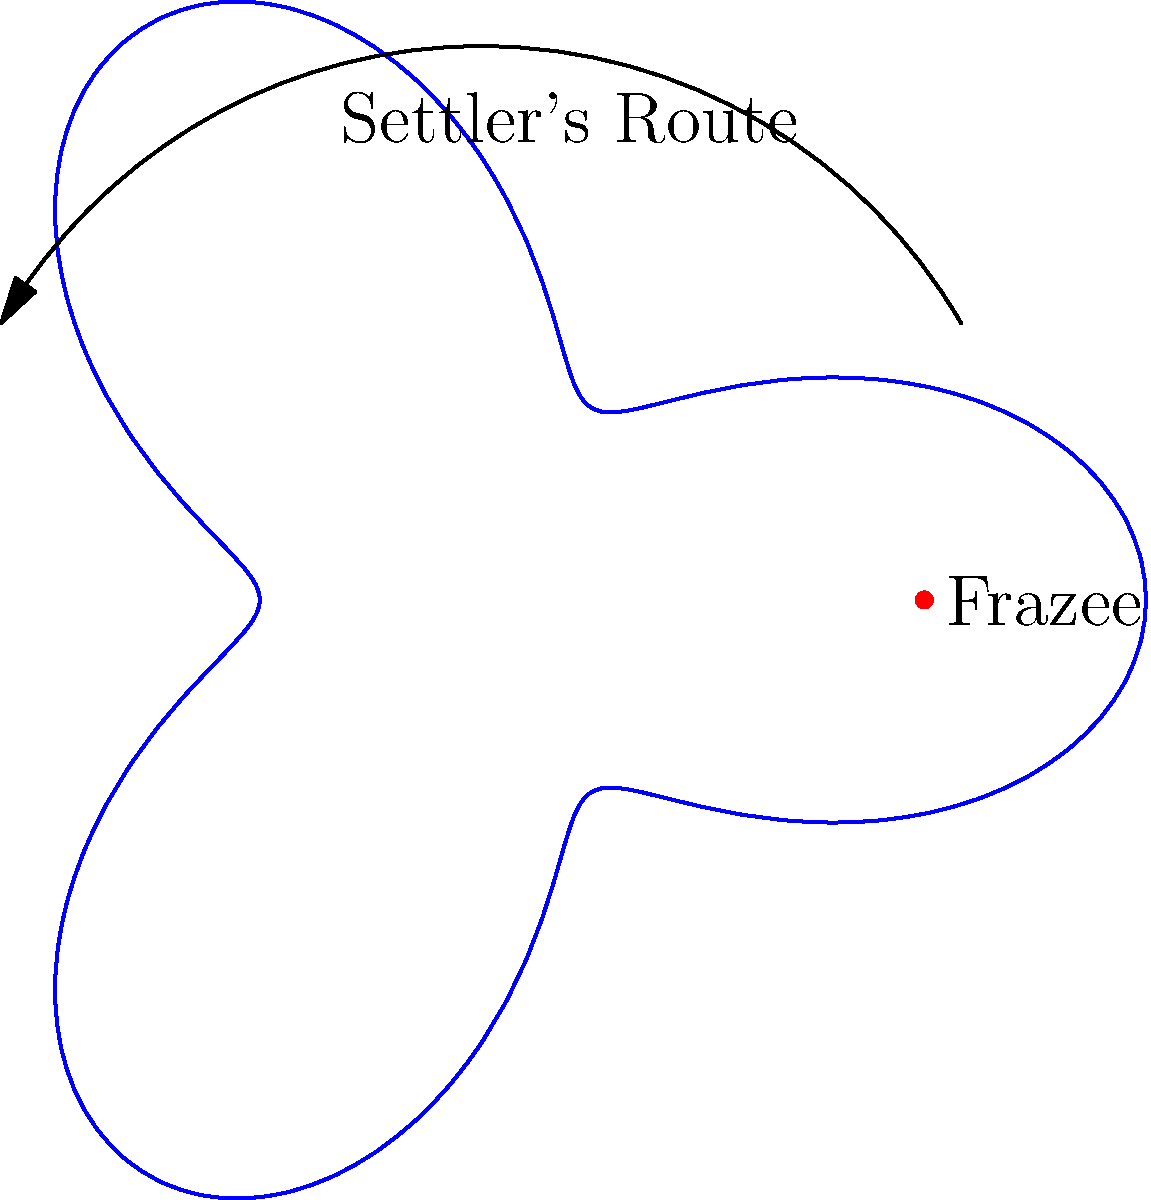In mapping the routes of early settlers to Frazee, a historian uses a rose curve defined by the polar equation $r = 2 + \cos(3\theta)$. If a settler's journey begins at the point $(3,0)$ in polar coordinates and ends at Frazee (represented by the point $(2,0)$), what is the total angular distance traveled by the settler along this curve? To solve this problem, we need to follow these steps:

1) The rose curve is defined by $r = 2 + \cos(3\theta)$. This curve has three petals due to the factor of 3 in the cosine term.

2) The settler starts at $(3,0)$ in polar coordinates. This means $r = 3$ and $\theta = 0$.

3) Frazee is located at $(2,0)$ in polar coordinates. This is the ending point of the journey.

4) To find the angular distance, we need to determine how many complete petals the settler traverses, plus any additional angle.

5) Each petal of the rose curve spans an angle of $\frac{2\pi}{3}$ radians (or 120°), as there are three petals in a full 360° rotation.

6) The settler starts outside the curve at $(3,0)$ and needs to reach $(2,0)$. To do this, they must travel through one complete petal and then an additional third of a petal.

7) Therefore, the total angular distance is:
   $\frac{2\pi}{3} + \frac{2\pi}{9} = \frac{8\pi}{9}$ radians

8) Converting to degrees: $\frac{8\pi}{9} \cdot \frac{180°}{\pi} = 160°$

Thus, the settler travels an angular distance of $\frac{8\pi}{9}$ radians or 160°.
Answer: $\frac{8\pi}{9}$ radians (or 160°) 